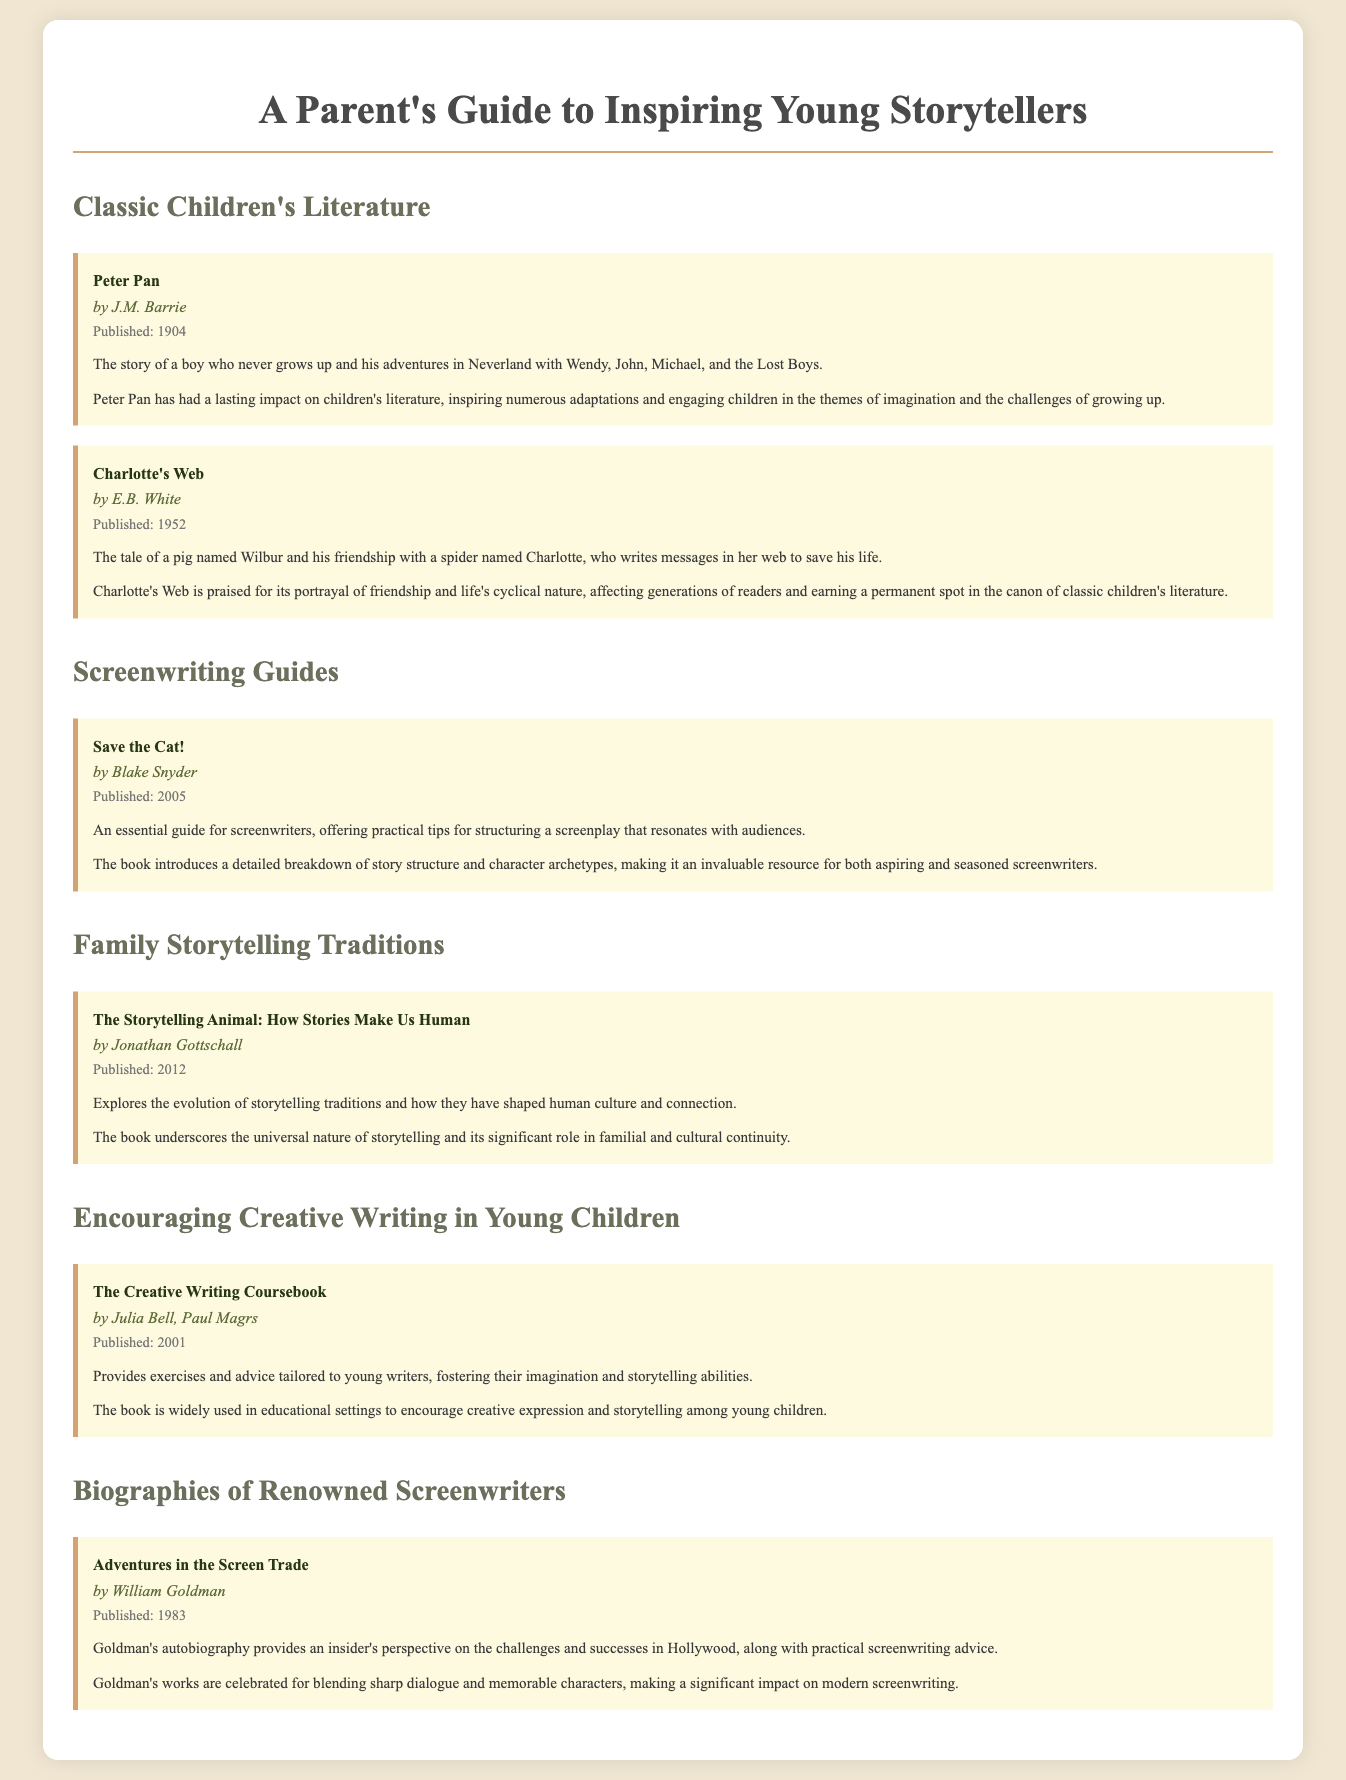What is the title of the book by J.M. Barrie? The title of the book is provided in the section about Classic Children's Literature under J.M. Barrie.
Answer: Peter Pan Who is the author of "Charlotte's Web"? The author of "Charlotte's Web" is mentioned in the same section of Classic Children's Literature.
Answer: E.B. White What year was "Save the Cat!" published? The publication year for "Save the Cat!" is directly listed in the screenwriting guides section.
Answer: 2005 What is the main topic of "The Storytelling Animal"? The main topic is summarized in the description, focusing on the evolution of storytelling traditions.
Answer: Evolution of storytelling traditions Which book is widely used in educational settings to encourage creative expression? The impact section mentions the book's widespread use in education, specifically targeting creative expression.
Answer: The Creative Writing Coursebook Who wrote "Adventures in the Screen Trade"? The author is listed at the beginning of the biography section of renowned screenwriters.
Answer: William Goldman What is the publication date of "Charlotte's Web"? The date is noted in the summary of Classic Children's Literature.
Answer: 1952 What genre does "Peter Pan" belong to? The content categorization is evident in the children's literature section of the document.
Answer: Children's Literature 